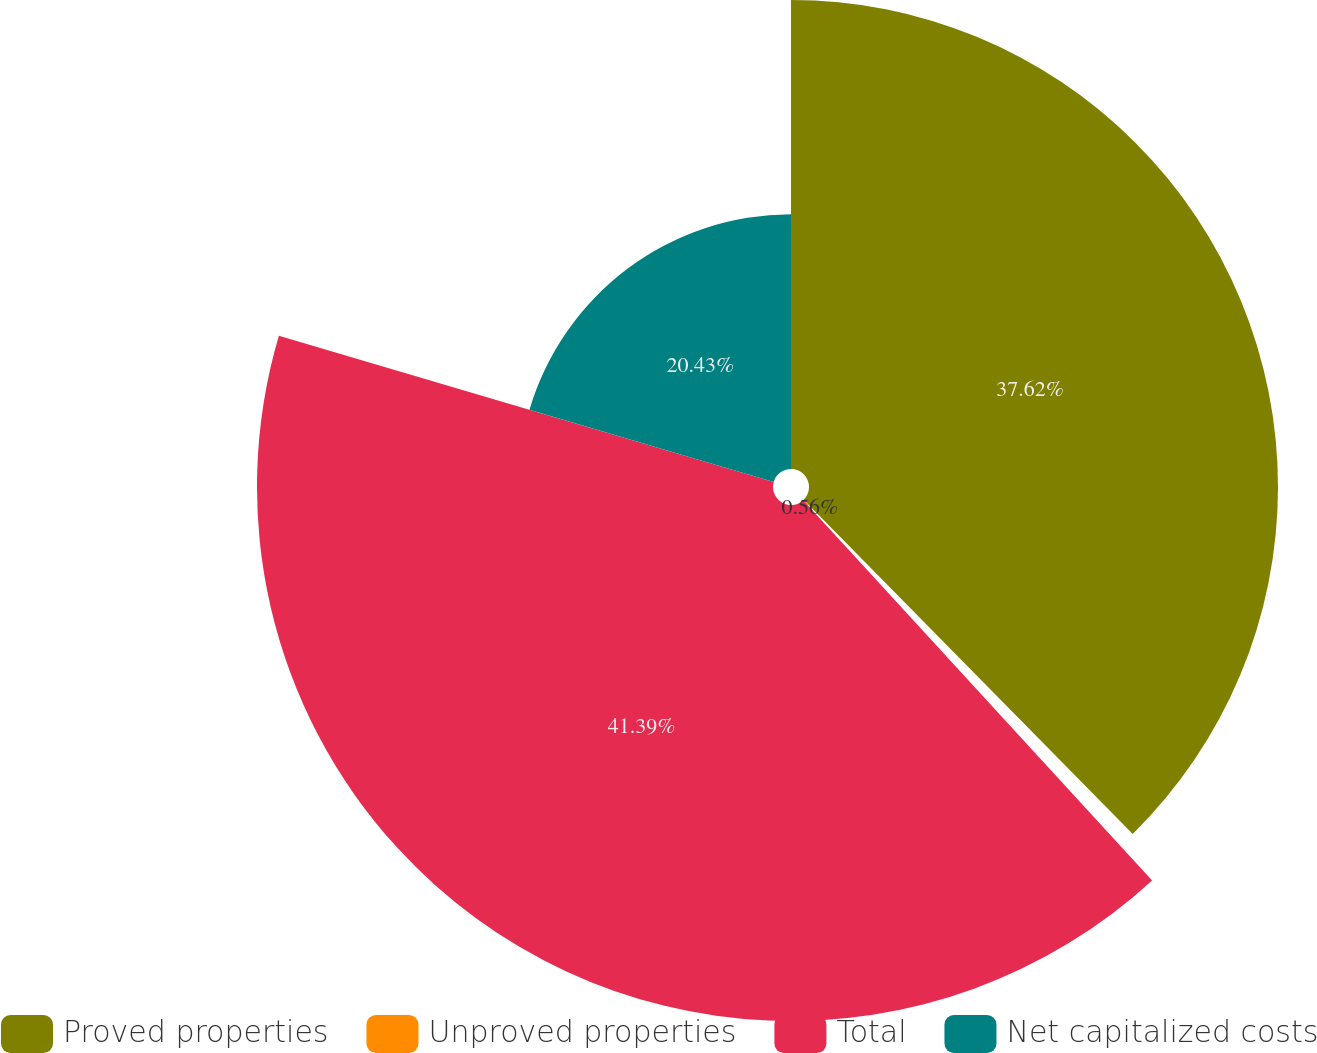Convert chart to OTSL. <chart><loc_0><loc_0><loc_500><loc_500><pie_chart><fcel>Proved properties<fcel>Unproved properties<fcel>Total<fcel>Net capitalized costs<nl><fcel>37.62%<fcel>0.56%<fcel>41.39%<fcel>20.43%<nl></chart> 